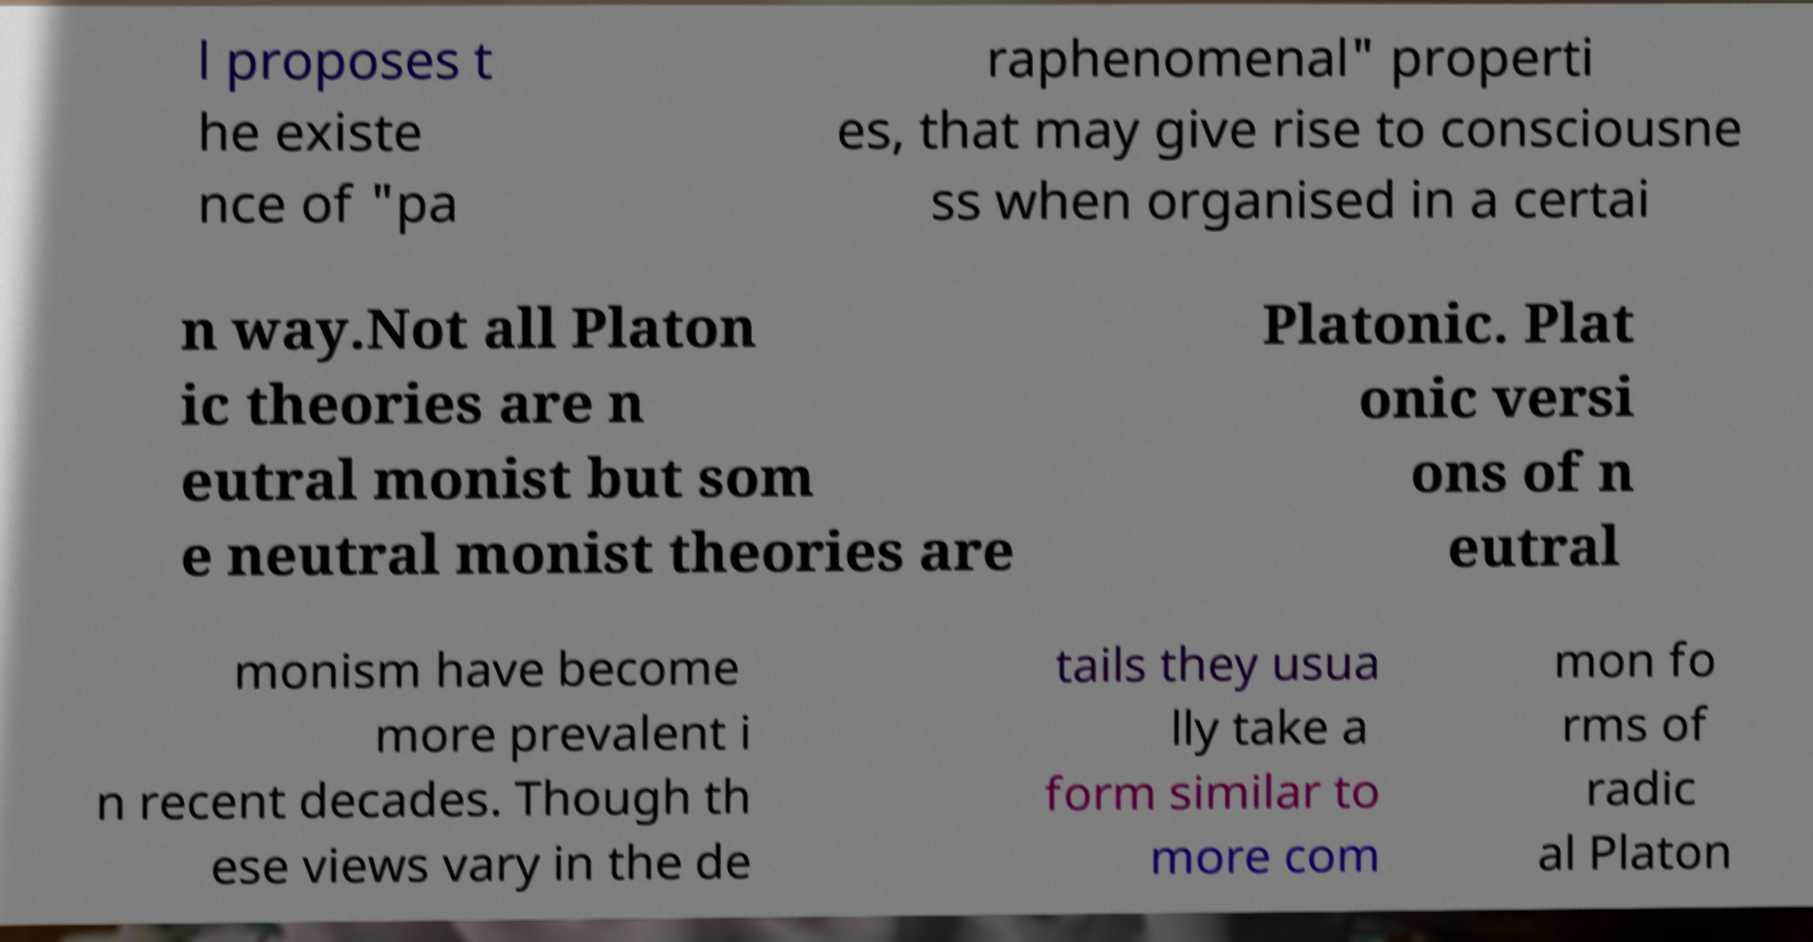Please read and relay the text visible in this image. What does it say? l proposes t he existe nce of "pa raphenomenal" properti es, that may give rise to consciousne ss when organised in a certai n way.Not all Platon ic theories are n eutral monist but som e neutral monist theories are Platonic. Plat onic versi ons of n eutral monism have become more prevalent i n recent decades. Though th ese views vary in the de tails they usua lly take a form similar to more com mon fo rms of radic al Platon 